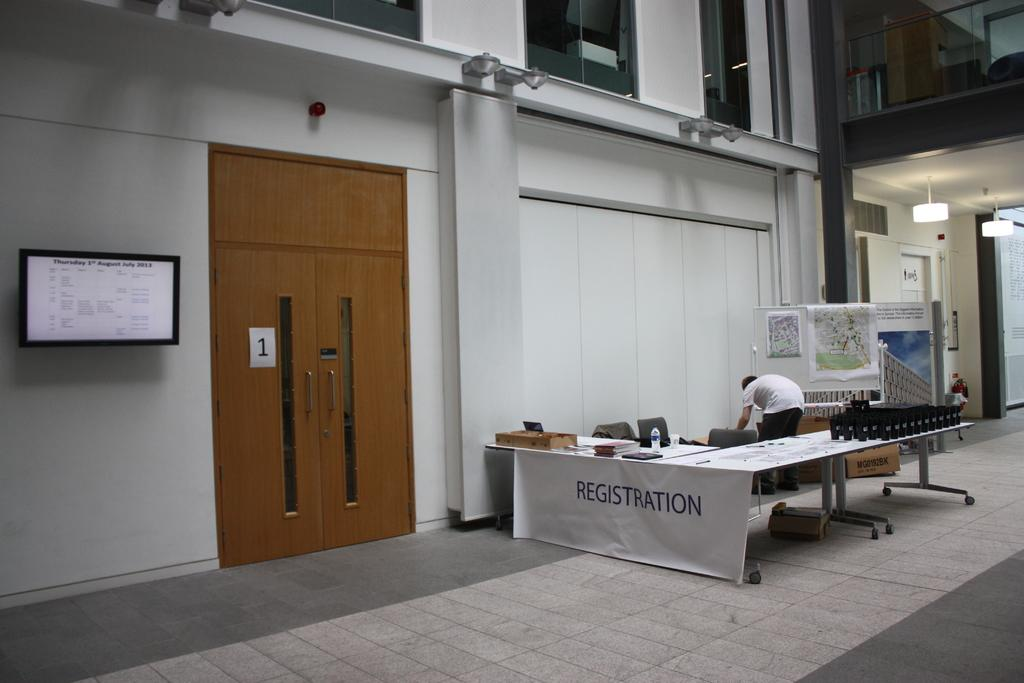What is the main subject in the image? There is a man standing in the image. What type of furniture can be seen in the image? There are chairs in the image. What is the object on the table in the image? There is a bottle in the image. What is hanging on the wall in the image? There is a banner in the image. What is attached to the board in the image? There are posters on a board in the image. What type of architectural feature is present in the image? There are doors in the image. What type of electronic device is present in the image? There is a television in the image. What type of lighting is present in the image? There are lights in the image. What type of surface is present in the image? There is a table in the image. What type of background is present in the image? There is a wall in the image. What type of container is present in the image? There is a glass in the image. What type of surface is under the man's feet in the image? There is a floor in the image. What type of decoration is present in the image? There is a sticker in the image. What type of objects are present in the image? There are some objects in the image. What is the distance between the man and the butter in the image? There is no butter present in the image, so it is not possible to determine the distance between the man and the butter. 